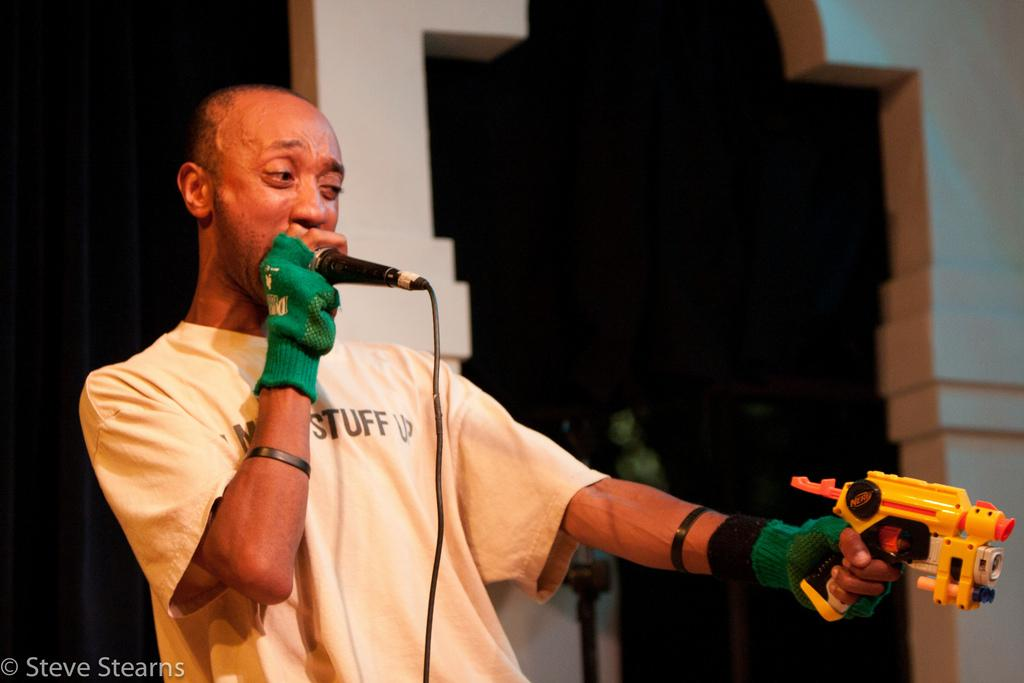What is the man in the image doing? The man is standing in the image. What object is the man holding in the image? The man is holding a toy gun. What accessory is the man wearing in the image? The man is wearing gloves. What equipment can be seen in the image? There is a mic in the image. What can be seen in the background of the image? There is a wall and a black curtain in the background of the image. How does the man kick the soccer ball in the image? There is no soccer ball present in the image, so the man cannot kick a soccer ball. 